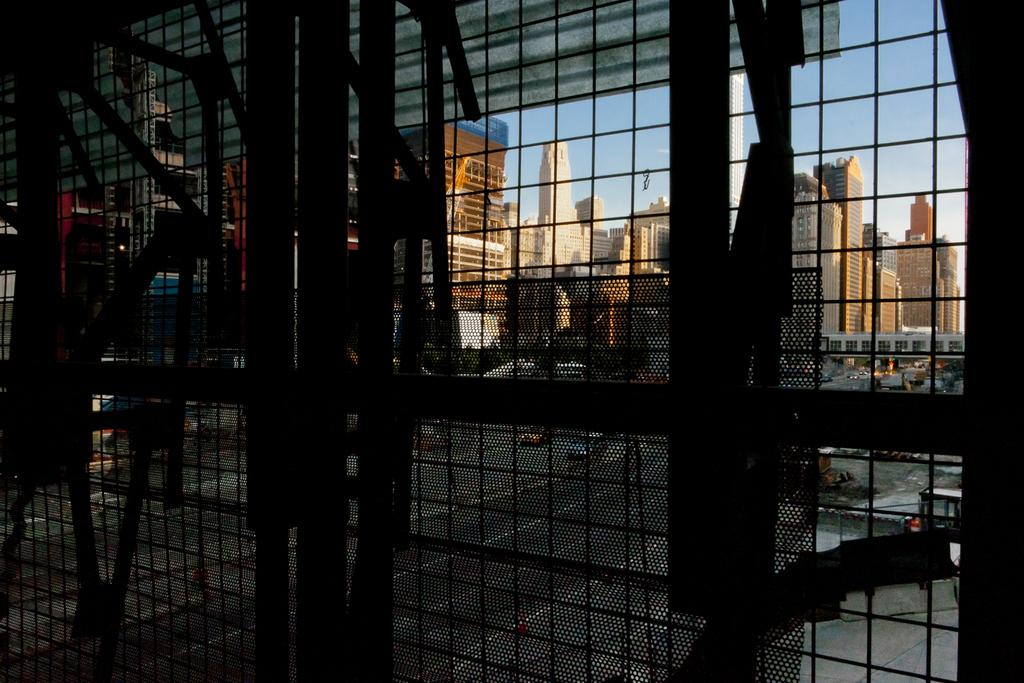What type of structure can be seen in the image? There is a fence in the image. What is visible beyond the fence? Buildings are visible through the fence. What part of the natural environment is visible in the image? The sky is visible in the image. How many light bulbs can be seen hanging from the fence in the image? There are no light bulbs present in the image; it features a fence, buildings, and the sky. 